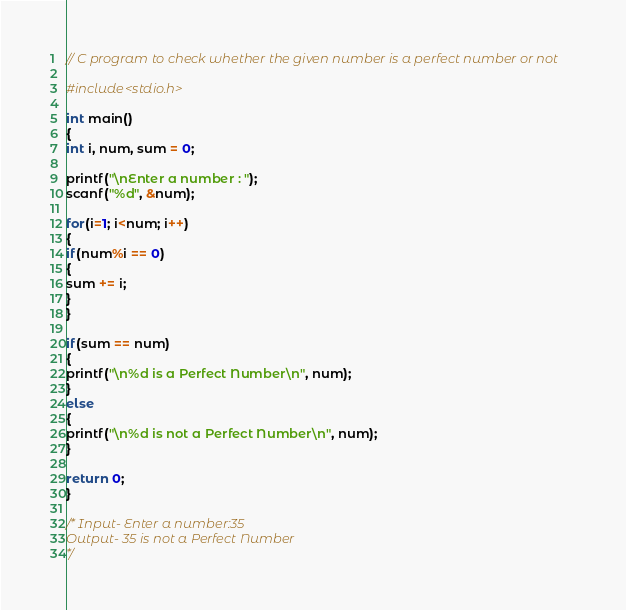<code> <loc_0><loc_0><loc_500><loc_500><_C_>// C program to check whether the given number is a perfect number or not

#include<stdio.h>

int main()
{
int i, num, sum = 0;

printf("\nEnter a number : ");
scanf("%d", &num);

for(i=1; i<num; i++)
{
if(num%i == 0)
{
sum += i;
}
}

if(sum == num)
{
printf("\n%d is a Perfect Number\n", num);
}
else
{
printf("\n%d is not a Perfect Number\n", num);
}

return 0;
}

/* Input- Enter a number:35 
Output- 35 is not a Perfect Number
*/

</code> 